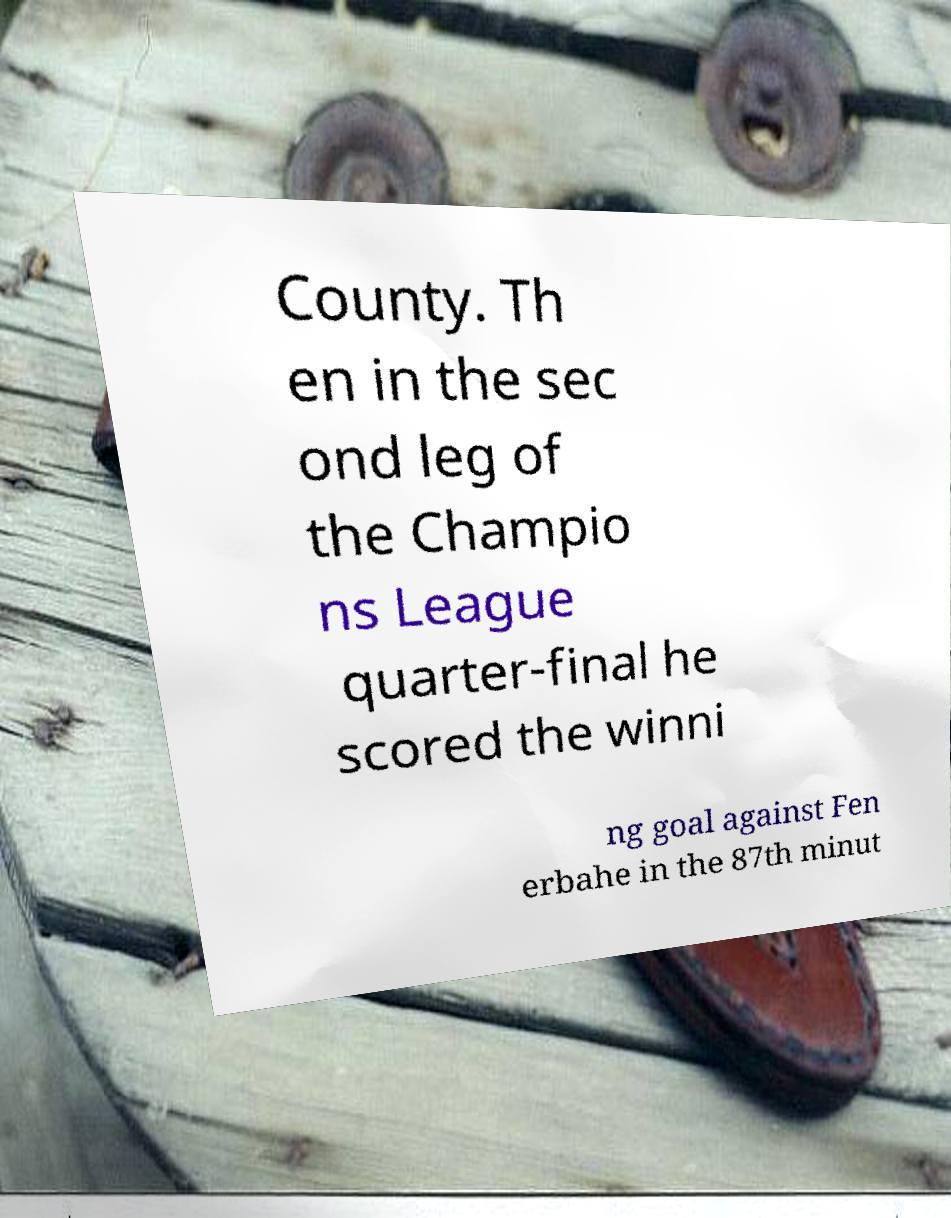What messages or text are displayed in this image? I need them in a readable, typed format. County. Th en in the sec ond leg of the Champio ns League quarter-final he scored the winni ng goal against Fen erbahe in the 87th minut 